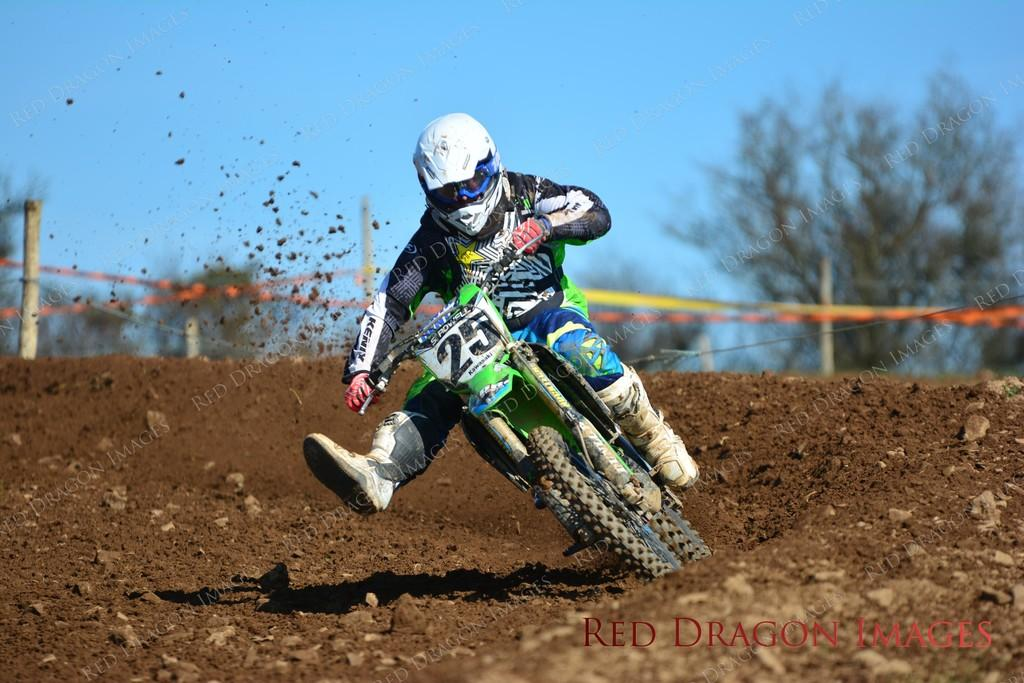<image>
Share a concise interpretation of the image provided. A dirt bike rider wearing the number 25 races around the corner. 